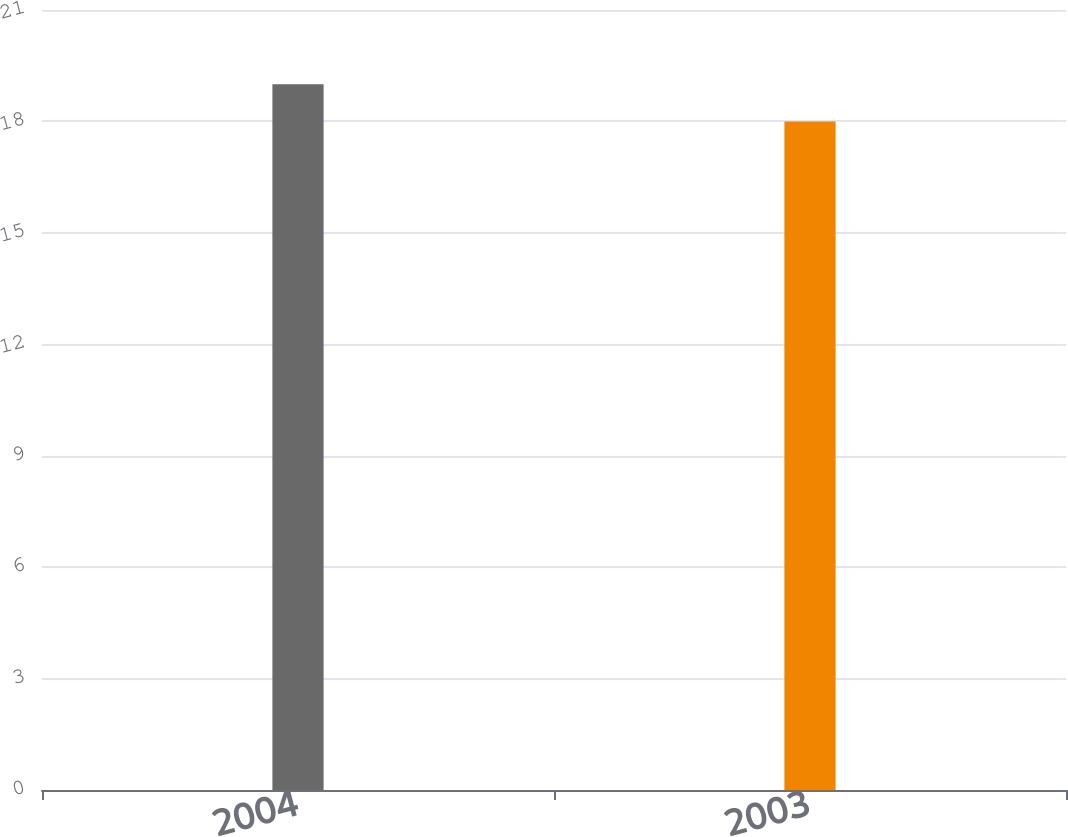Convert chart to OTSL. <chart><loc_0><loc_0><loc_500><loc_500><bar_chart><fcel>2004<fcel>2003<nl><fcel>19<fcel>18<nl></chart> 